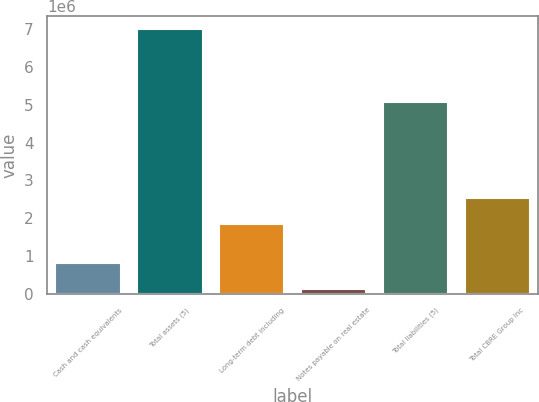<chart> <loc_0><loc_0><loc_500><loc_500><bar_chart><fcel>Cash and cash equivalents<fcel>Total assets (5)<fcel>Long-term debt including<fcel>Notes payable on real estate<fcel>Total liabilities (5)<fcel>Total CBRE Group Inc<nl><fcel>817266<fcel>6.99841e+06<fcel>1.84068e+06<fcel>130472<fcel>5.06241e+06<fcel>2.52747e+06<nl></chart> 